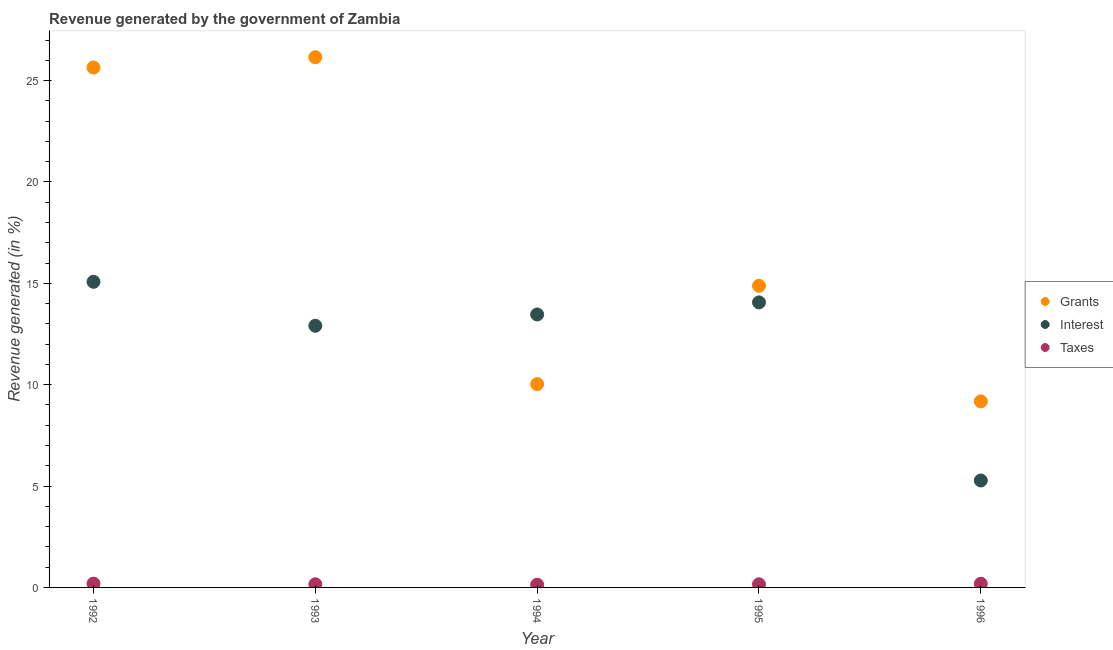What is the percentage of revenue generated by interest in 1995?
Make the answer very short. 14.06. Across all years, what is the maximum percentage of revenue generated by grants?
Offer a terse response. 26.15. Across all years, what is the minimum percentage of revenue generated by taxes?
Your answer should be very brief. 0.14. In which year was the percentage of revenue generated by grants minimum?
Your answer should be compact. 1996. What is the total percentage of revenue generated by interest in the graph?
Your answer should be very brief. 60.78. What is the difference between the percentage of revenue generated by taxes in 1994 and that in 1996?
Provide a short and direct response. -0.05. What is the difference between the percentage of revenue generated by interest in 1996 and the percentage of revenue generated by grants in 1992?
Provide a short and direct response. -20.37. What is the average percentage of revenue generated by interest per year?
Your response must be concise. 12.16. In the year 1993, what is the difference between the percentage of revenue generated by interest and percentage of revenue generated by taxes?
Offer a terse response. 12.75. What is the ratio of the percentage of revenue generated by grants in 1992 to that in 1994?
Your answer should be compact. 2.56. What is the difference between the highest and the second highest percentage of revenue generated by interest?
Offer a very short reply. 1.02. What is the difference between the highest and the lowest percentage of revenue generated by grants?
Ensure brevity in your answer.  16.98. In how many years, is the percentage of revenue generated by grants greater than the average percentage of revenue generated by grants taken over all years?
Offer a terse response. 2. Is the sum of the percentage of revenue generated by interest in 1995 and 1996 greater than the maximum percentage of revenue generated by grants across all years?
Give a very brief answer. No. Is it the case that in every year, the sum of the percentage of revenue generated by grants and percentage of revenue generated by interest is greater than the percentage of revenue generated by taxes?
Offer a very short reply. Yes. Does the percentage of revenue generated by grants monotonically increase over the years?
Your answer should be compact. No. Is the percentage of revenue generated by taxes strictly less than the percentage of revenue generated by grants over the years?
Provide a short and direct response. Yes. How many years are there in the graph?
Your response must be concise. 5. Where does the legend appear in the graph?
Your response must be concise. Center right. How many legend labels are there?
Offer a very short reply. 3. What is the title of the graph?
Give a very brief answer. Revenue generated by the government of Zambia. Does "Infant(male)" appear as one of the legend labels in the graph?
Your answer should be compact. No. What is the label or title of the Y-axis?
Your response must be concise. Revenue generated (in %). What is the Revenue generated (in %) in Grants in 1992?
Make the answer very short. 25.64. What is the Revenue generated (in %) of Interest in 1992?
Provide a short and direct response. 15.07. What is the Revenue generated (in %) in Taxes in 1992?
Provide a succinct answer. 0.19. What is the Revenue generated (in %) in Grants in 1993?
Your response must be concise. 26.15. What is the Revenue generated (in %) in Interest in 1993?
Provide a short and direct response. 12.91. What is the Revenue generated (in %) in Taxes in 1993?
Your answer should be compact. 0.16. What is the Revenue generated (in %) of Grants in 1994?
Offer a terse response. 10.03. What is the Revenue generated (in %) in Interest in 1994?
Keep it short and to the point. 13.46. What is the Revenue generated (in %) in Taxes in 1994?
Provide a succinct answer. 0.14. What is the Revenue generated (in %) in Grants in 1995?
Your response must be concise. 14.88. What is the Revenue generated (in %) in Interest in 1995?
Keep it short and to the point. 14.06. What is the Revenue generated (in %) in Taxes in 1995?
Provide a short and direct response. 0.15. What is the Revenue generated (in %) of Grants in 1996?
Offer a terse response. 9.18. What is the Revenue generated (in %) of Interest in 1996?
Keep it short and to the point. 5.27. What is the Revenue generated (in %) in Taxes in 1996?
Offer a terse response. 0.18. Across all years, what is the maximum Revenue generated (in %) in Grants?
Offer a very short reply. 26.15. Across all years, what is the maximum Revenue generated (in %) in Interest?
Make the answer very short. 15.07. Across all years, what is the maximum Revenue generated (in %) of Taxes?
Your answer should be very brief. 0.19. Across all years, what is the minimum Revenue generated (in %) in Grants?
Your answer should be very brief. 9.18. Across all years, what is the minimum Revenue generated (in %) of Interest?
Give a very brief answer. 5.27. Across all years, what is the minimum Revenue generated (in %) in Taxes?
Provide a short and direct response. 0.14. What is the total Revenue generated (in %) of Grants in the graph?
Offer a very short reply. 85.88. What is the total Revenue generated (in %) in Interest in the graph?
Provide a short and direct response. 60.78. What is the total Revenue generated (in %) in Taxes in the graph?
Provide a succinct answer. 0.81. What is the difference between the Revenue generated (in %) of Grants in 1992 and that in 1993?
Your answer should be compact. -0.51. What is the difference between the Revenue generated (in %) of Interest in 1992 and that in 1993?
Give a very brief answer. 2.17. What is the difference between the Revenue generated (in %) in Taxes in 1992 and that in 1993?
Provide a short and direct response. 0.03. What is the difference between the Revenue generated (in %) in Grants in 1992 and that in 1994?
Give a very brief answer. 15.61. What is the difference between the Revenue generated (in %) in Interest in 1992 and that in 1994?
Your response must be concise. 1.61. What is the difference between the Revenue generated (in %) of Taxes in 1992 and that in 1994?
Keep it short and to the point. 0.05. What is the difference between the Revenue generated (in %) in Grants in 1992 and that in 1995?
Give a very brief answer. 10.76. What is the difference between the Revenue generated (in %) of Interest in 1992 and that in 1995?
Your answer should be very brief. 1.02. What is the difference between the Revenue generated (in %) in Taxes in 1992 and that in 1995?
Offer a terse response. 0.03. What is the difference between the Revenue generated (in %) in Grants in 1992 and that in 1996?
Provide a succinct answer. 16.47. What is the difference between the Revenue generated (in %) in Interest in 1992 and that in 1996?
Offer a terse response. 9.8. What is the difference between the Revenue generated (in %) in Taxes in 1992 and that in 1996?
Provide a succinct answer. 0. What is the difference between the Revenue generated (in %) in Grants in 1993 and that in 1994?
Your answer should be very brief. 16.12. What is the difference between the Revenue generated (in %) in Interest in 1993 and that in 1994?
Offer a very short reply. -0.56. What is the difference between the Revenue generated (in %) in Taxes in 1993 and that in 1994?
Your answer should be very brief. 0.02. What is the difference between the Revenue generated (in %) in Grants in 1993 and that in 1995?
Your response must be concise. 11.27. What is the difference between the Revenue generated (in %) in Interest in 1993 and that in 1995?
Ensure brevity in your answer.  -1.15. What is the difference between the Revenue generated (in %) of Taxes in 1993 and that in 1995?
Your answer should be compact. 0. What is the difference between the Revenue generated (in %) of Grants in 1993 and that in 1996?
Offer a terse response. 16.98. What is the difference between the Revenue generated (in %) of Interest in 1993 and that in 1996?
Give a very brief answer. 7.63. What is the difference between the Revenue generated (in %) of Taxes in 1993 and that in 1996?
Offer a very short reply. -0.03. What is the difference between the Revenue generated (in %) of Grants in 1994 and that in 1995?
Your response must be concise. -4.85. What is the difference between the Revenue generated (in %) in Interest in 1994 and that in 1995?
Offer a very short reply. -0.6. What is the difference between the Revenue generated (in %) of Taxes in 1994 and that in 1995?
Keep it short and to the point. -0.02. What is the difference between the Revenue generated (in %) in Grants in 1994 and that in 1996?
Ensure brevity in your answer.  0.85. What is the difference between the Revenue generated (in %) in Interest in 1994 and that in 1996?
Your response must be concise. 8.19. What is the difference between the Revenue generated (in %) in Taxes in 1994 and that in 1996?
Make the answer very short. -0.05. What is the difference between the Revenue generated (in %) in Grants in 1995 and that in 1996?
Your answer should be very brief. 5.7. What is the difference between the Revenue generated (in %) of Interest in 1995 and that in 1996?
Ensure brevity in your answer.  8.78. What is the difference between the Revenue generated (in %) of Taxes in 1995 and that in 1996?
Provide a short and direct response. -0.03. What is the difference between the Revenue generated (in %) of Grants in 1992 and the Revenue generated (in %) of Interest in 1993?
Give a very brief answer. 12.74. What is the difference between the Revenue generated (in %) in Grants in 1992 and the Revenue generated (in %) in Taxes in 1993?
Keep it short and to the point. 25.49. What is the difference between the Revenue generated (in %) of Interest in 1992 and the Revenue generated (in %) of Taxes in 1993?
Provide a succinct answer. 14.92. What is the difference between the Revenue generated (in %) in Grants in 1992 and the Revenue generated (in %) in Interest in 1994?
Your answer should be very brief. 12.18. What is the difference between the Revenue generated (in %) of Grants in 1992 and the Revenue generated (in %) of Taxes in 1994?
Your answer should be very brief. 25.51. What is the difference between the Revenue generated (in %) of Interest in 1992 and the Revenue generated (in %) of Taxes in 1994?
Offer a terse response. 14.94. What is the difference between the Revenue generated (in %) of Grants in 1992 and the Revenue generated (in %) of Interest in 1995?
Keep it short and to the point. 11.58. What is the difference between the Revenue generated (in %) in Grants in 1992 and the Revenue generated (in %) in Taxes in 1995?
Provide a succinct answer. 25.49. What is the difference between the Revenue generated (in %) of Interest in 1992 and the Revenue generated (in %) of Taxes in 1995?
Your answer should be very brief. 14.92. What is the difference between the Revenue generated (in %) of Grants in 1992 and the Revenue generated (in %) of Interest in 1996?
Make the answer very short. 20.37. What is the difference between the Revenue generated (in %) of Grants in 1992 and the Revenue generated (in %) of Taxes in 1996?
Your answer should be very brief. 25.46. What is the difference between the Revenue generated (in %) of Interest in 1992 and the Revenue generated (in %) of Taxes in 1996?
Your answer should be compact. 14.89. What is the difference between the Revenue generated (in %) in Grants in 1993 and the Revenue generated (in %) in Interest in 1994?
Offer a very short reply. 12.69. What is the difference between the Revenue generated (in %) of Grants in 1993 and the Revenue generated (in %) of Taxes in 1994?
Give a very brief answer. 26.02. What is the difference between the Revenue generated (in %) of Interest in 1993 and the Revenue generated (in %) of Taxes in 1994?
Provide a succinct answer. 12.77. What is the difference between the Revenue generated (in %) of Grants in 1993 and the Revenue generated (in %) of Interest in 1995?
Your answer should be compact. 12.09. What is the difference between the Revenue generated (in %) of Grants in 1993 and the Revenue generated (in %) of Taxes in 1995?
Offer a very short reply. 26. What is the difference between the Revenue generated (in %) in Interest in 1993 and the Revenue generated (in %) in Taxes in 1995?
Your answer should be compact. 12.75. What is the difference between the Revenue generated (in %) of Grants in 1993 and the Revenue generated (in %) of Interest in 1996?
Offer a very short reply. 20.88. What is the difference between the Revenue generated (in %) in Grants in 1993 and the Revenue generated (in %) in Taxes in 1996?
Your response must be concise. 25.97. What is the difference between the Revenue generated (in %) of Interest in 1993 and the Revenue generated (in %) of Taxes in 1996?
Keep it short and to the point. 12.72. What is the difference between the Revenue generated (in %) in Grants in 1994 and the Revenue generated (in %) in Interest in 1995?
Provide a short and direct response. -4.03. What is the difference between the Revenue generated (in %) in Grants in 1994 and the Revenue generated (in %) in Taxes in 1995?
Keep it short and to the point. 9.87. What is the difference between the Revenue generated (in %) in Interest in 1994 and the Revenue generated (in %) in Taxes in 1995?
Your answer should be very brief. 13.31. What is the difference between the Revenue generated (in %) in Grants in 1994 and the Revenue generated (in %) in Interest in 1996?
Make the answer very short. 4.75. What is the difference between the Revenue generated (in %) in Grants in 1994 and the Revenue generated (in %) in Taxes in 1996?
Offer a very short reply. 9.85. What is the difference between the Revenue generated (in %) of Interest in 1994 and the Revenue generated (in %) of Taxes in 1996?
Keep it short and to the point. 13.28. What is the difference between the Revenue generated (in %) in Grants in 1995 and the Revenue generated (in %) in Interest in 1996?
Your answer should be very brief. 9.6. What is the difference between the Revenue generated (in %) of Grants in 1995 and the Revenue generated (in %) of Taxes in 1996?
Give a very brief answer. 14.7. What is the difference between the Revenue generated (in %) of Interest in 1995 and the Revenue generated (in %) of Taxes in 1996?
Offer a very short reply. 13.88. What is the average Revenue generated (in %) in Grants per year?
Your answer should be compact. 17.18. What is the average Revenue generated (in %) in Interest per year?
Offer a very short reply. 12.16. What is the average Revenue generated (in %) of Taxes per year?
Provide a succinct answer. 0.16. In the year 1992, what is the difference between the Revenue generated (in %) in Grants and Revenue generated (in %) in Interest?
Offer a terse response. 10.57. In the year 1992, what is the difference between the Revenue generated (in %) of Grants and Revenue generated (in %) of Taxes?
Ensure brevity in your answer.  25.46. In the year 1992, what is the difference between the Revenue generated (in %) of Interest and Revenue generated (in %) of Taxes?
Make the answer very short. 14.89. In the year 1993, what is the difference between the Revenue generated (in %) of Grants and Revenue generated (in %) of Interest?
Provide a short and direct response. 13.25. In the year 1993, what is the difference between the Revenue generated (in %) in Grants and Revenue generated (in %) in Taxes?
Offer a terse response. 26. In the year 1993, what is the difference between the Revenue generated (in %) in Interest and Revenue generated (in %) in Taxes?
Your answer should be compact. 12.75. In the year 1994, what is the difference between the Revenue generated (in %) in Grants and Revenue generated (in %) in Interest?
Offer a very short reply. -3.44. In the year 1994, what is the difference between the Revenue generated (in %) in Grants and Revenue generated (in %) in Taxes?
Keep it short and to the point. 9.89. In the year 1994, what is the difference between the Revenue generated (in %) in Interest and Revenue generated (in %) in Taxes?
Offer a terse response. 13.33. In the year 1995, what is the difference between the Revenue generated (in %) of Grants and Revenue generated (in %) of Interest?
Ensure brevity in your answer.  0.82. In the year 1995, what is the difference between the Revenue generated (in %) in Grants and Revenue generated (in %) in Taxes?
Ensure brevity in your answer.  14.72. In the year 1995, what is the difference between the Revenue generated (in %) in Interest and Revenue generated (in %) in Taxes?
Provide a succinct answer. 13.9. In the year 1996, what is the difference between the Revenue generated (in %) in Grants and Revenue generated (in %) in Interest?
Your answer should be compact. 3.9. In the year 1996, what is the difference between the Revenue generated (in %) of Grants and Revenue generated (in %) of Taxes?
Ensure brevity in your answer.  8.99. In the year 1996, what is the difference between the Revenue generated (in %) of Interest and Revenue generated (in %) of Taxes?
Make the answer very short. 5.09. What is the ratio of the Revenue generated (in %) of Grants in 1992 to that in 1993?
Provide a short and direct response. 0.98. What is the ratio of the Revenue generated (in %) of Interest in 1992 to that in 1993?
Offer a very short reply. 1.17. What is the ratio of the Revenue generated (in %) of Taxes in 1992 to that in 1993?
Your answer should be compact. 1.19. What is the ratio of the Revenue generated (in %) in Grants in 1992 to that in 1994?
Ensure brevity in your answer.  2.56. What is the ratio of the Revenue generated (in %) of Interest in 1992 to that in 1994?
Your answer should be compact. 1.12. What is the ratio of the Revenue generated (in %) of Taxes in 1992 to that in 1994?
Your answer should be very brief. 1.38. What is the ratio of the Revenue generated (in %) in Grants in 1992 to that in 1995?
Your answer should be very brief. 1.72. What is the ratio of the Revenue generated (in %) in Interest in 1992 to that in 1995?
Ensure brevity in your answer.  1.07. What is the ratio of the Revenue generated (in %) of Taxes in 1992 to that in 1995?
Provide a short and direct response. 1.21. What is the ratio of the Revenue generated (in %) in Grants in 1992 to that in 1996?
Your answer should be compact. 2.79. What is the ratio of the Revenue generated (in %) in Interest in 1992 to that in 1996?
Your answer should be very brief. 2.86. What is the ratio of the Revenue generated (in %) in Taxes in 1992 to that in 1996?
Keep it short and to the point. 1.03. What is the ratio of the Revenue generated (in %) in Grants in 1993 to that in 1994?
Ensure brevity in your answer.  2.61. What is the ratio of the Revenue generated (in %) of Interest in 1993 to that in 1994?
Your answer should be very brief. 0.96. What is the ratio of the Revenue generated (in %) in Taxes in 1993 to that in 1994?
Offer a terse response. 1.16. What is the ratio of the Revenue generated (in %) of Grants in 1993 to that in 1995?
Provide a short and direct response. 1.76. What is the ratio of the Revenue generated (in %) of Interest in 1993 to that in 1995?
Keep it short and to the point. 0.92. What is the ratio of the Revenue generated (in %) in Taxes in 1993 to that in 1995?
Give a very brief answer. 1.01. What is the ratio of the Revenue generated (in %) of Grants in 1993 to that in 1996?
Provide a succinct answer. 2.85. What is the ratio of the Revenue generated (in %) in Interest in 1993 to that in 1996?
Keep it short and to the point. 2.45. What is the ratio of the Revenue generated (in %) of Taxes in 1993 to that in 1996?
Offer a very short reply. 0.86. What is the ratio of the Revenue generated (in %) of Grants in 1994 to that in 1995?
Your response must be concise. 0.67. What is the ratio of the Revenue generated (in %) in Interest in 1994 to that in 1995?
Your answer should be compact. 0.96. What is the ratio of the Revenue generated (in %) of Taxes in 1994 to that in 1995?
Keep it short and to the point. 0.88. What is the ratio of the Revenue generated (in %) in Grants in 1994 to that in 1996?
Ensure brevity in your answer.  1.09. What is the ratio of the Revenue generated (in %) in Interest in 1994 to that in 1996?
Provide a succinct answer. 2.55. What is the ratio of the Revenue generated (in %) of Taxes in 1994 to that in 1996?
Give a very brief answer. 0.74. What is the ratio of the Revenue generated (in %) in Grants in 1995 to that in 1996?
Offer a terse response. 1.62. What is the ratio of the Revenue generated (in %) in Interest in 1995 to that in 1996?
Your answer should be compact. 2.67. What is the ratio of the Revenue generated (in %) of Taxes in 1995 to that in 1996?
Your response must be concise. 0.85. What is the difference between the highest and the second highest Revenue generated (in %) of Grants?
Offer a very short reply. 0.51. What is the difference between the highest and the second highest Revenue generated (in %) of Interest?
Give a very brief answer. 1.02. What is the difference between the highest and the second highest Revenue generated (in %) in Taxes?
Give a very brief answer. 0. What is the difference between the highest and the lowest Revenue generated (in %) of Grants?
Your response must be concise. 16.98. What is the difference between the highest and the lowest Revenue generated (in %) in Interest?
Provide a short and direct response. 9.8. What is the difference between the highest and the lowest Revenue generated (in %) in Taxes?
Provide a short and direct response. 0.05. 